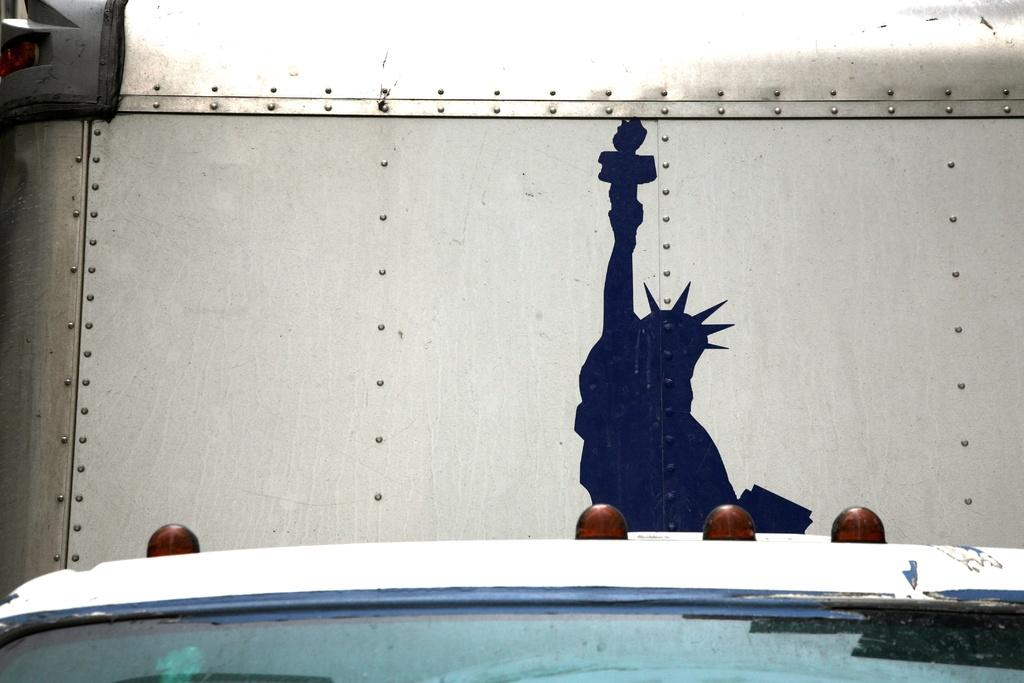What is the main subject of the image? There is a statue of liberty in the image. What is the color of the poster in the image? The image is a black poster. Where is the poster located? The poster is on a steel wall. Can you describe any other objects or people in the image? There might be a white car at the bottom of the image, and there are four bald heads visible behind the car. What type of calendar is hanging on the wing of the car in the image? There is no calendar or wing present in the image; it features a black poster with the Statue of Liberty on a steel wall, a white car, and four bald heads visible behind the car. 